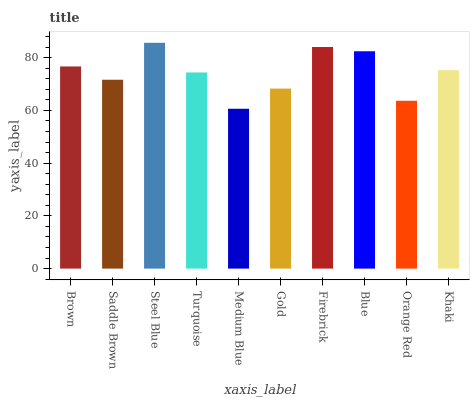Is Medium Blue the minimum?
Answer yes or no. Yes. Is Steel Blue the maximum?
Answer yes or no. Yes. Is Saddle Brown the minimum?
Answer yes or no. No. Is Saddle Brown the maximum?
Answer yes or no. No. Is Brown greater than Saddle Brown?
Answer yes or no. Yes. Is Saddle Brown less than Brown?
Answer yes or no. Yes. Is Saddle Brown greater than Brown?
Answer yes or no. No. Is Brown less than Saddle Brown?
Answer yes or no. No. Is Khaki the high median?
Answer yes or no. Yes. Is Turquoise the low median?
Answer yes or no. Yes. Is Orange Red the high median?
Answer yes or no. No. Is Medium Blue the low median?
Answer yes or no. No. 